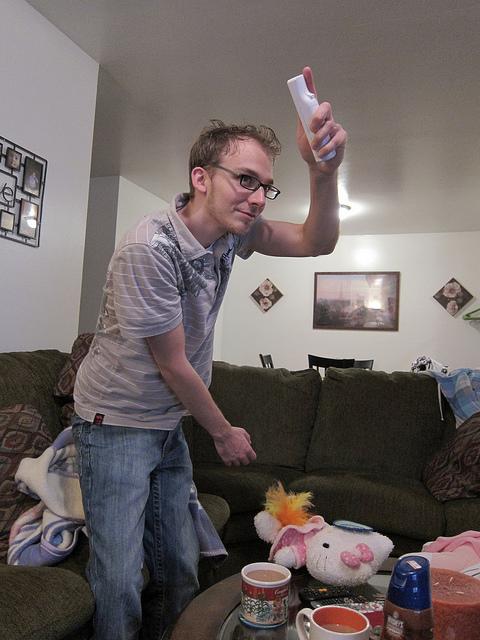Are there windows in this room?
Keep it brief. No. What type of seating is in the room?
Answer briefly. Couch. Is there cake?
Concise answer only. No. Does the man wear glasses?
Concise answer only. Yes. What is this man doing?
Short answer required. Playing wii. What is the man holding?
Concise answer only. Wii remote. How many people are wearing glasses?
Quick response, please. 1. 